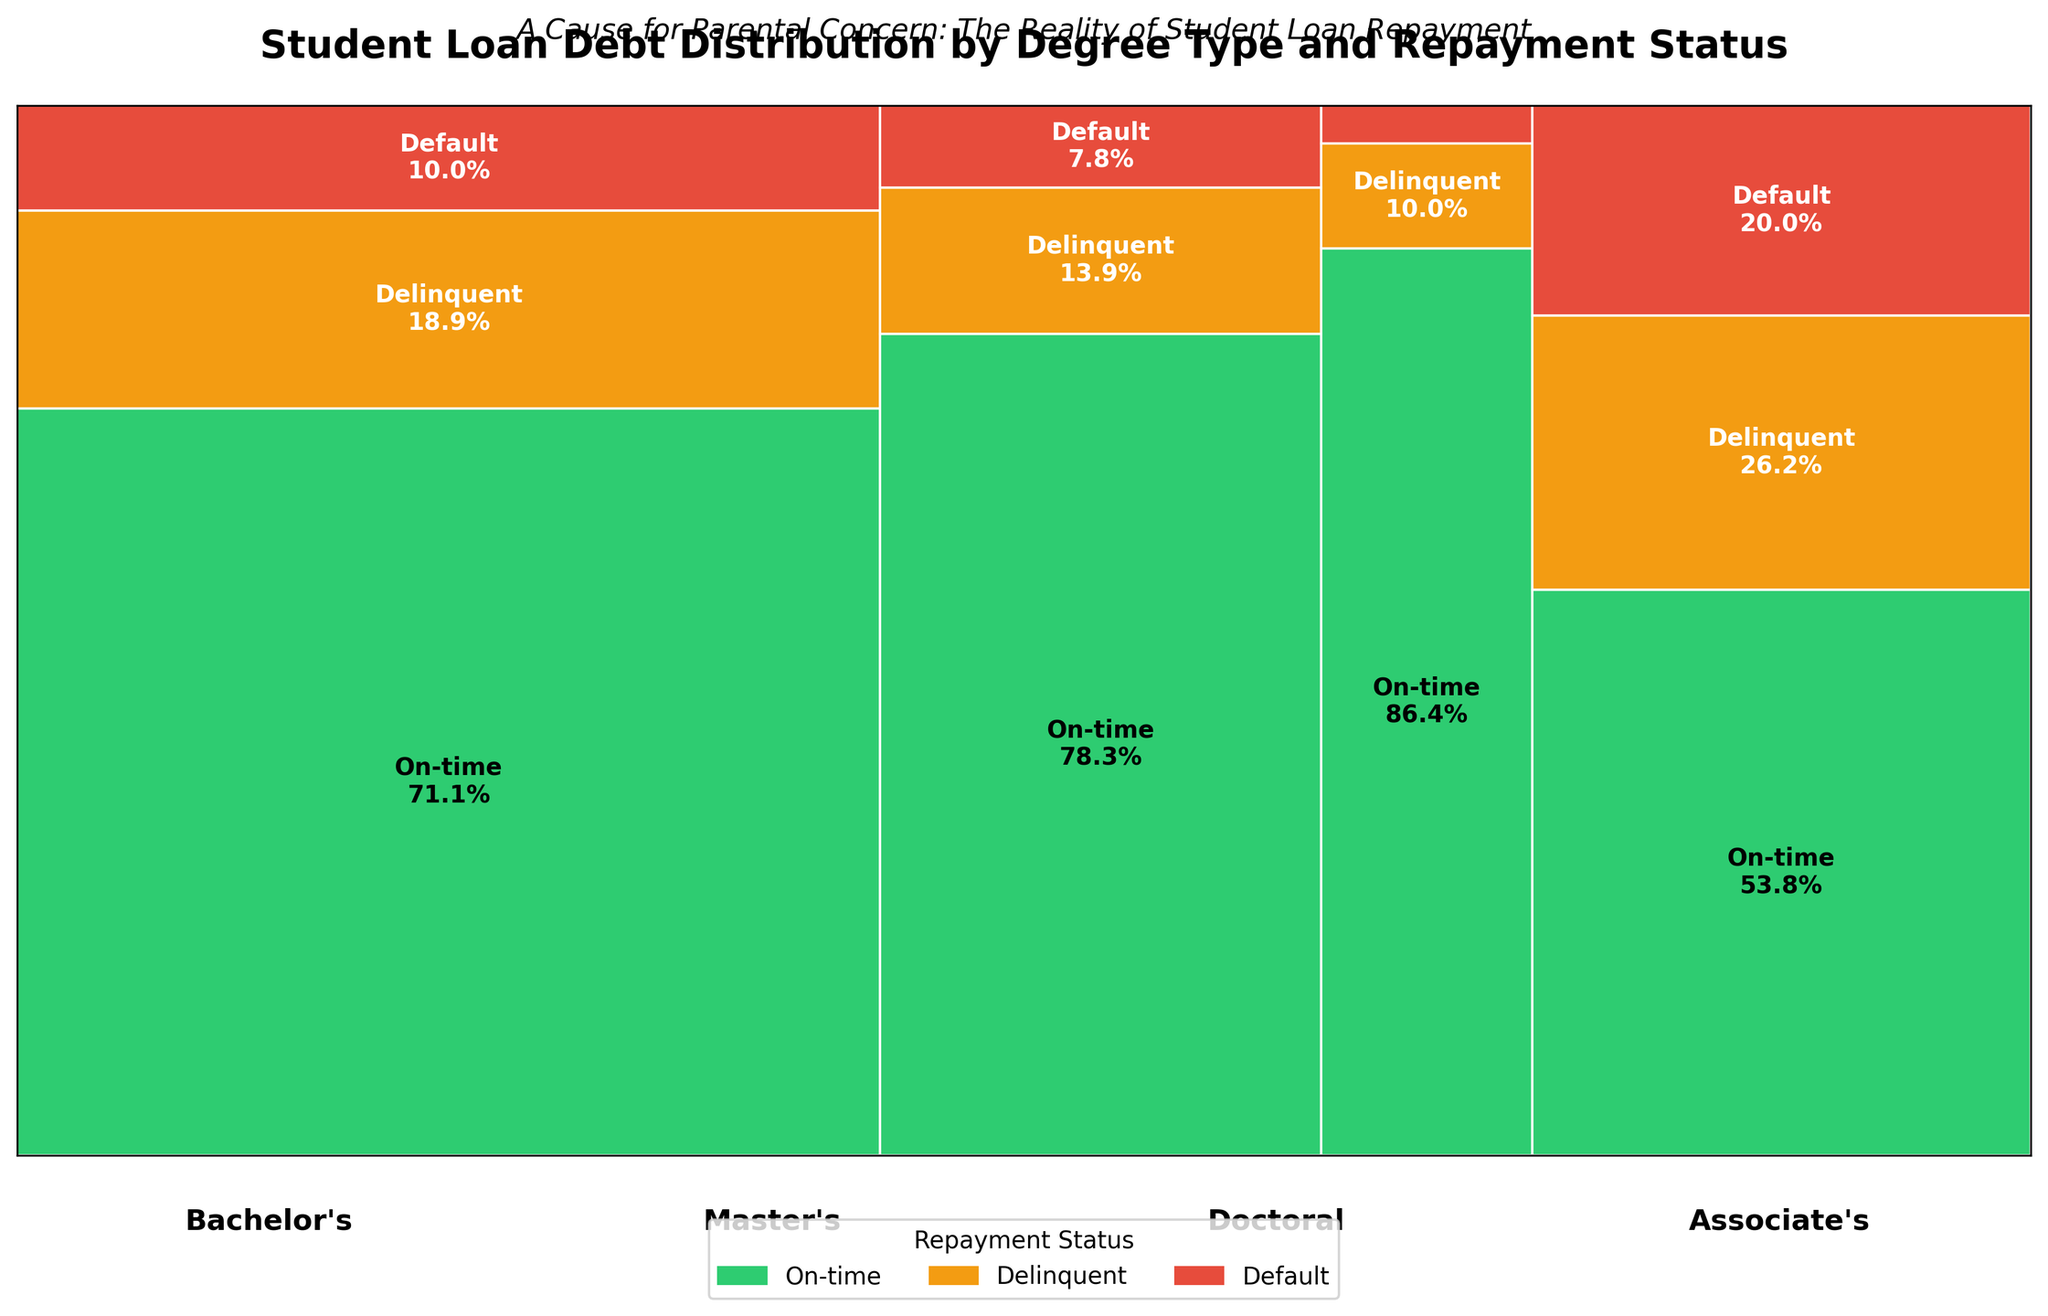What is the title of the plot? The title of the plot is typically at the top of the figure in larger or bold text.
Answer: "Student Loan Debt Distribution by Degree Type and Repayment Status" Which degree type has the highest proportion of on-time repayments? From each mosaic block corresponding to different degree types, observe which has the largest green section (denoting on-time repayments).
Answer: Bachelor's What percentage of Master's degree holders are in default? Look at the red section within the Master's degree category and read the percentage label inside it.
Answer: 6.0% Among the Doctoral degree holders, is the proportion of delinquents greater than the proportion of those in default? Compare the sizes (heights) of the orange (delinquent) and red (default) sections for Doctoral degree holders.
Answer: Yes What is the ratio of delinquent to on-time repayments among Associate's degree holders? Compare the sizes of the orange (delinquent) and green (on-time) sections within the Associate's degree category.
Answer: 680/1400 For which degree type is the proportion of defaulters the smallest? Identify the smallest red section among all degree categories.
Answer: Doctoral How does the number of defaulted student loans for Bachelor's degrees compare to Associate's degrees? Compare the numerical data provided in the dataset for default counts in Bachelor's and Associate's degrees.
Answer: Bachelor's: 450, Associate's: 520 What visual elements are used to represent different repayment statuses? Each repayment status is represented by a distinct color within the mosaic plot. Green for on-time, orange for delinquent, and red for default.
Answer: Colors Which degree type has a higher proportion of delinquent payments, Bachelor's or Master's? Compare the sizes of the orange (delinquent) sections for Bachelor's and Master's degree categories.
Answer: Bachelor's Is the sum of delinquent and defaulted loans greater for Bachelor's degree holders than all other degree types combined? Sum the counts of delinquent and default for Bachelor's and compare to the sum across all other degree types.
Answer: Yes 